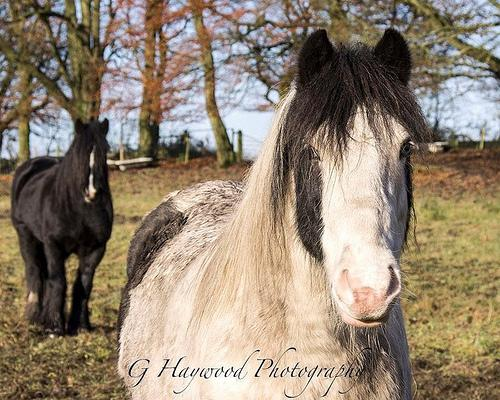Question: what is the season?
Choices:
A. Winter.
B. Spring.
C. Fall.
D. Summer.
Answer with the letter. Answer: C Question: who took the photo?
Choices:
A. Richard Avedon.
B. Annie Leibovitz.
C. Ansel Adams.
D. G Haywood Photography.
Answer with the letter. Answer: D Question: where are the horses?
Choices:
A. On the meadow.
B. Pasture.
C. On the beach.
D. In the stables.
Answer with the letter. Answer: B Question: how many horses?
Choices:
A. Two.
B. One.
C. Four.
D. Five.
Answer with the letter. Answer: A 